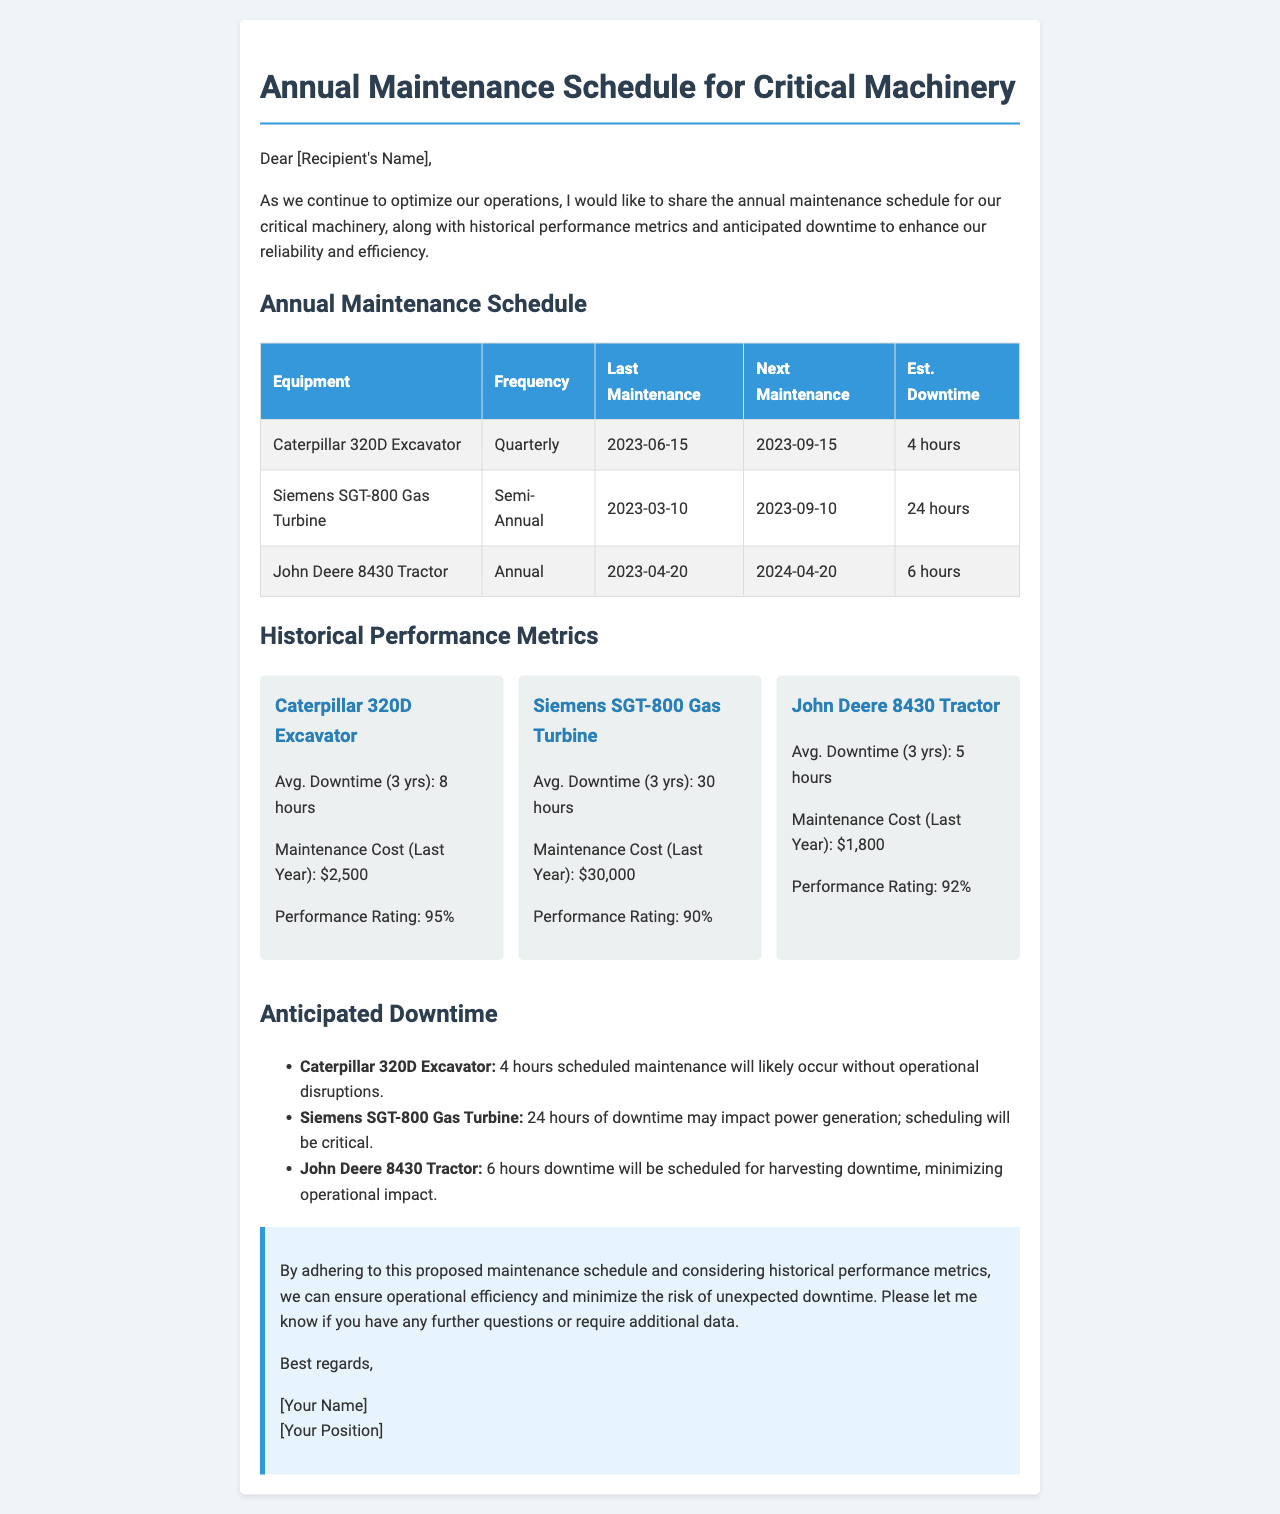what is the next maintenance date for the Caterpillar 320D Excavator? The next maintenance date is mentioned in the schedule table for the Caterpillar 320D Excavator, which is September 15, 2023.
Answer: September 15, 2023 how many hours of downtime are anticipated for the Siemens SGT-800 Gas Turbine? The anticipated downtime for the Siemens SGT-800 Gas Turbine is specified in the Anticipated Downtime section, which states 24 hours.
Answer: 24 hours what was the maintenance cost for the Caterpillar 320D Excavator last year? The maintenance cost for the Caterpillar 320D Excavator is provided in the Historical Performance Metrics section, which states $2,500.
Answer: $2,500 which equipment has the highest average downtime over three years? The Historical Performance Metrics section lists the average downtime for each piece of equipment, where the Siemens SGT-800 Gas Turbine has the highest average downtime of 30 hours.
Answer: Siemens SGT-800 Gas Turbine how often is the John Deere 8430 Tractor maintained? The frequency of maintenance for the John Deere 8430 Tractor is detailed in the schedule table, which indicates it is maintained annually.
Answer: Annual what is the performance rating of the Siemens SGT-800 Gas Turbine? The performance rating for the Siemens SGT-800 Gas Turbine is included in the Historical Performance Metrics section, which shows a rating of 90%.
Answer: 90% how is the anticipated downtime for the John Deere 8430 Tractor scheduled to minimize impact? The document explains that the 6 hours of downtime for the John Deere 8430 Tractor will be scheduled during harvesting to minimize operational impact.
Answer: During harvesting how many pieces of equipment are mentioned in the maintenance schedule? The maintenance schedule includes three pieces of equipment as listed in the table: Caterpillar 320D Excavator, Siemens SGT-800 Gas Turbine, and John Deere 8430 Tractor.
Answer: Three 